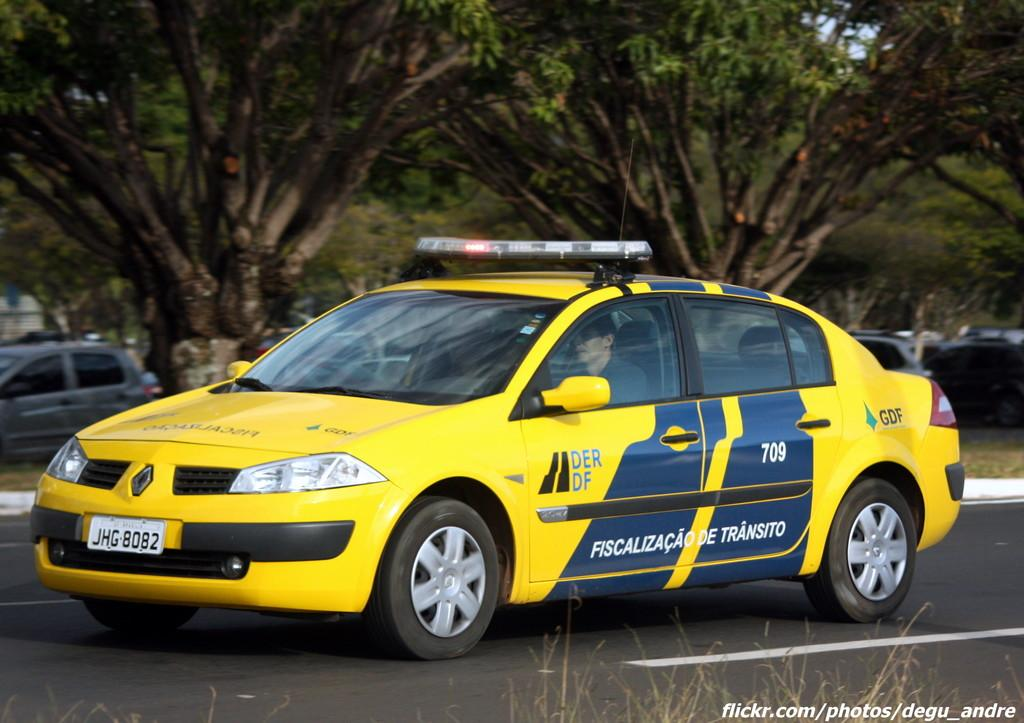Provide a one-sentence caption for the provided image. A European police car with plate number JHG 8082. 